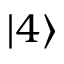Convert formula to latex. <formula><loc_0><loc_0><loc_500><loc_500>| 4 \rangle</formula> 